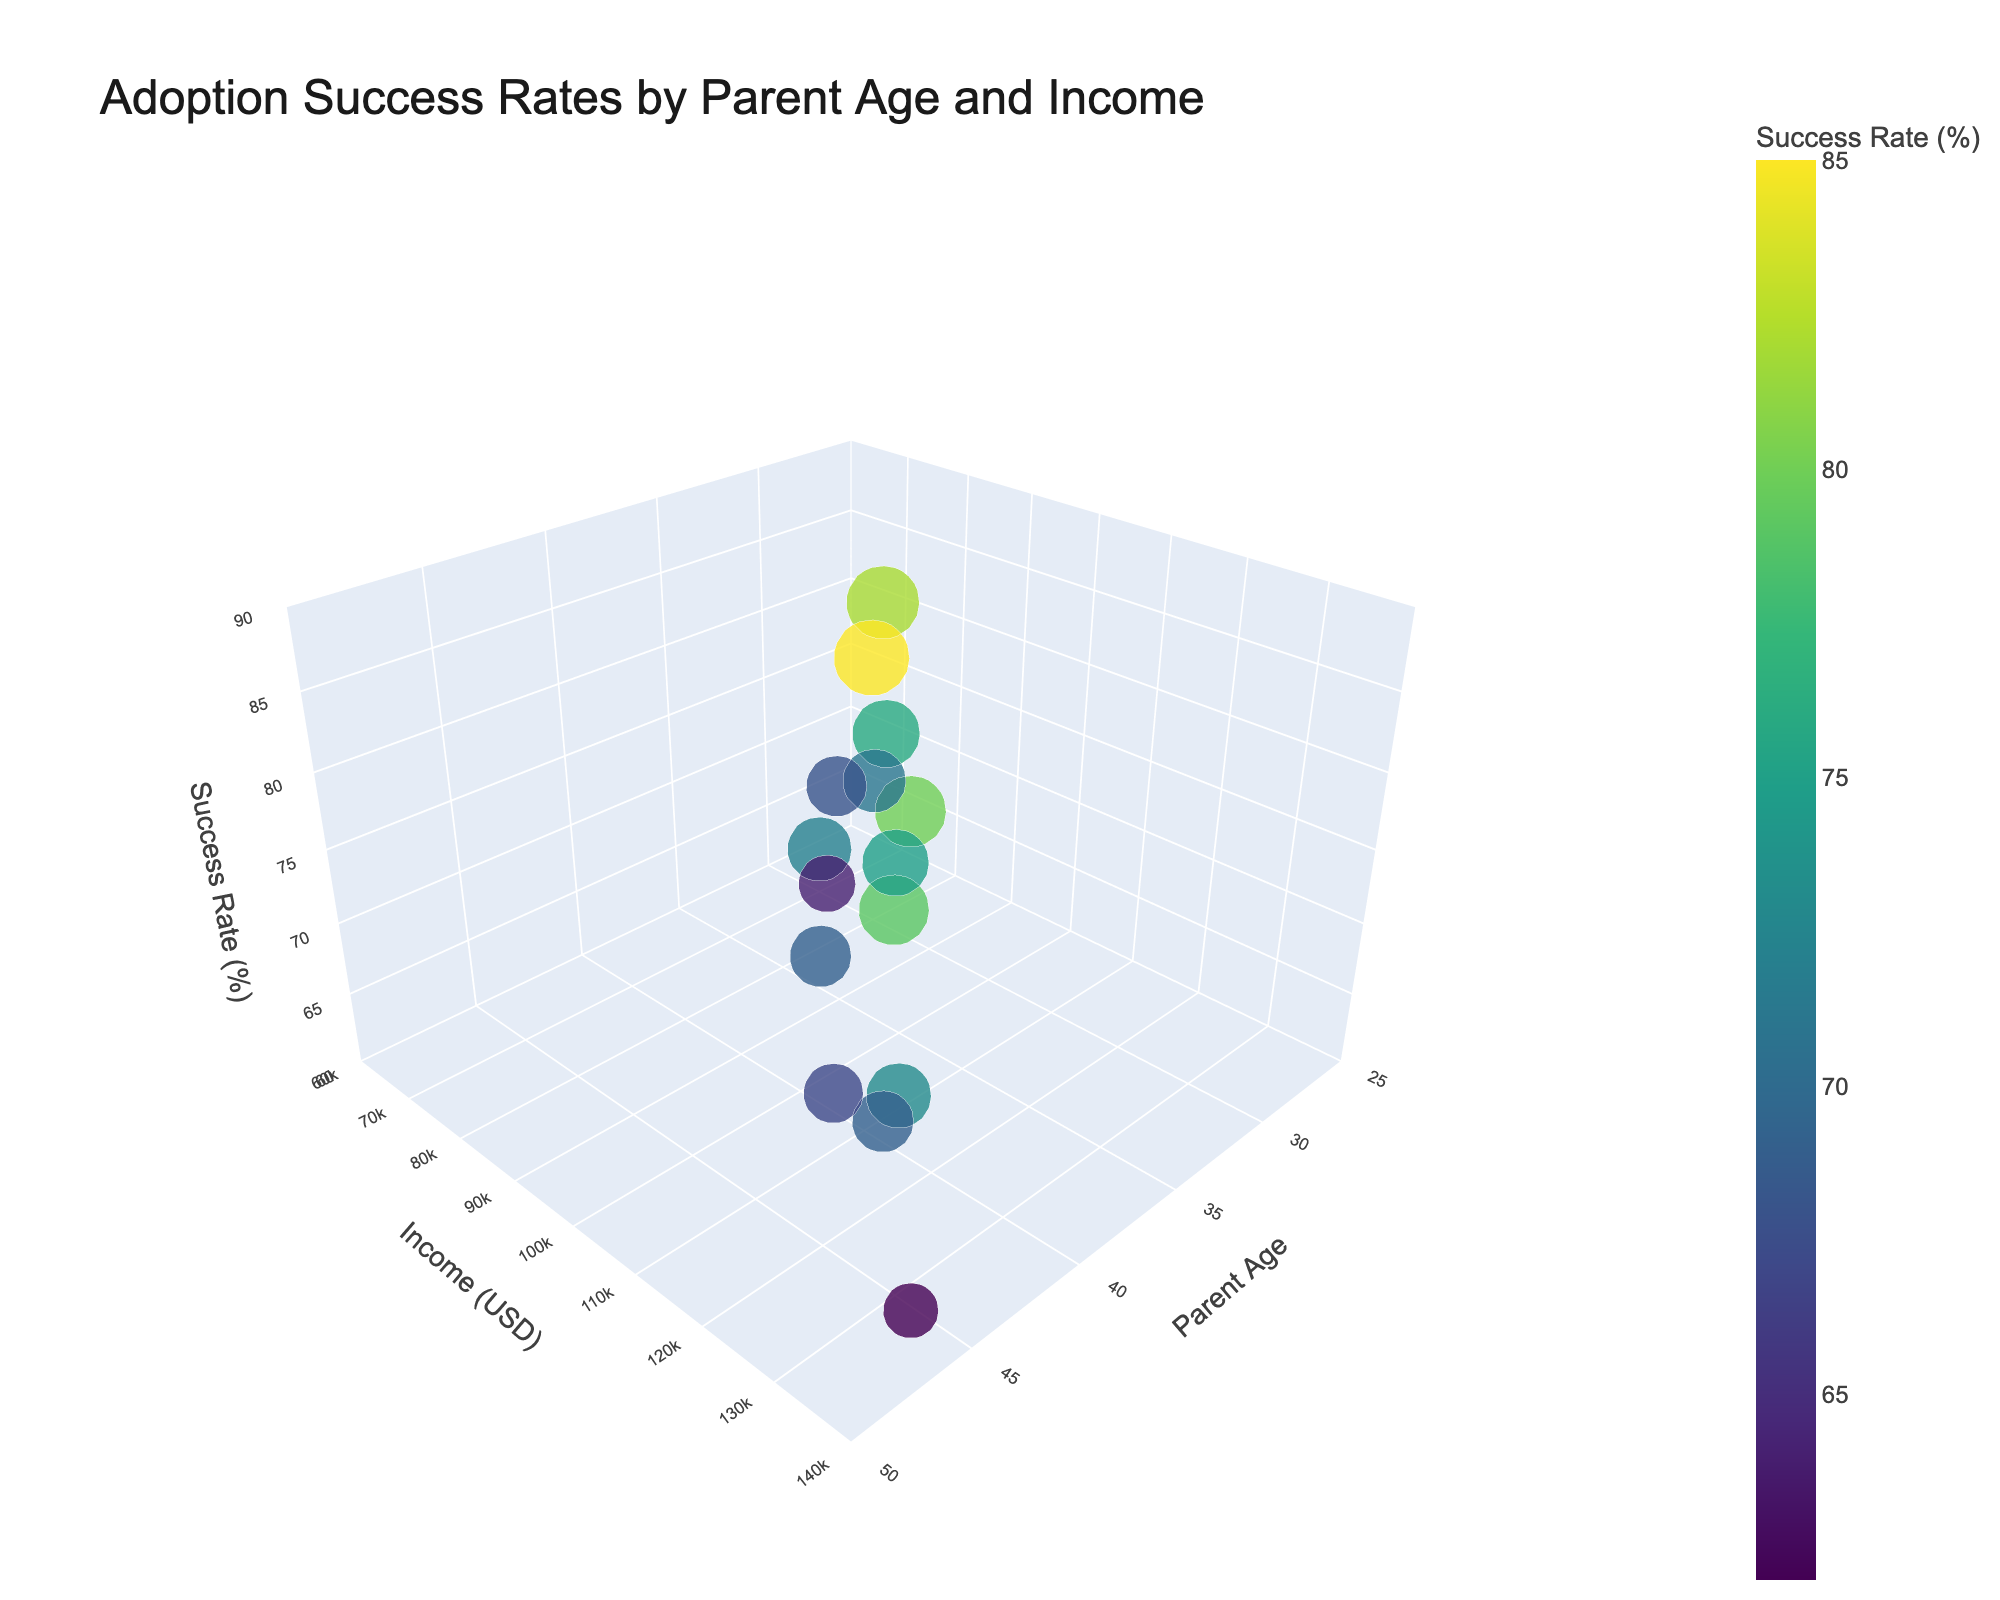What is the title of the figure? The title is positioned at the top of the figure, indicating the focus of the data visualization.
Answer: Adoption Success Rates by Parent Age and Income What are the labels for the axes? The labels for the axes are visible and describe the variables plotted. The X-axis is labeled "Parent Age," the Y-axis is labeled "Income (USD)," and the Z-axis is labeled "Success Rate (%)".
Answer: Parent Age, Income (USD), Success Rate (%) How many data points are on the plot? Count the number of individual bubbles representing data points in the 3D scatter plot.
Answer: 15 Which adoption method has the highest success rate and what is it? Look for the largest bubble (highest Z-axis position) and check the label when you hover over it. The largest bubble corresponds to the domestic infant adoption by parents aged 35 with an income of 95000 USD.
Answer: Domestic Infant, 85% What is the success rate for international adoptions (Ethiopia) by parents aged 44? Identify the data point for international adoptions (Ethiopia) with parent age 44 and check the Z-axis value.
Answer: 69% Which adoption method generally shows the highest success rates? Compare the general heights and sizes of bubbles across different methods to determine the trend. Domestic infant adoptions have the highest success rates overall, evident by larger and higher-positioned bubbles.
Answer: Domestic Infant How do success rates for foster care change with increasing parent age? Observe the trend of bubbles for foster care across the X-axis (parent age) to see if the success rate increases, decreases, or stays constant. As parent age increases (29, 36, 43), the success rate slightly decreases (68%, 72%, 67%).
Answer: Decreases slightly Which two adoption methods show the closest success rates for parents aged 37 with an income of around 105000 USD? Locate data points and compare bubbles for parents aged 37 across different methods with similar incomes. Both international adoptions from Ethiopia and China have success rates around 75% and 80%, respectively.
Answer: International (Ethiopia) and International (China) What is the range of incomes depicted on the plot? Examine the Y-axis label and note the minimum and maximum income values. The range is from 70000 USD to 135000 USD.
Answer: 70000 USD to 135000 USD Between domestic and international (China) adoption methods, which shows a higher variance in success rates, and how can you tell? Compare the spread of the bubbles' Z-axis positions within each method. Domestic adoptions show a variance between 79% and 85%, while international (China) adoptions range from 73% to 80%, indicating domestic adoptions demonstrate slightly more consistency and less variance.
Answer: International (China) shows higher variance 